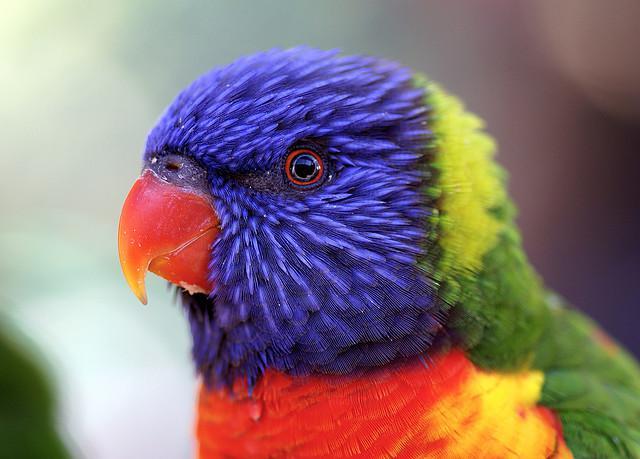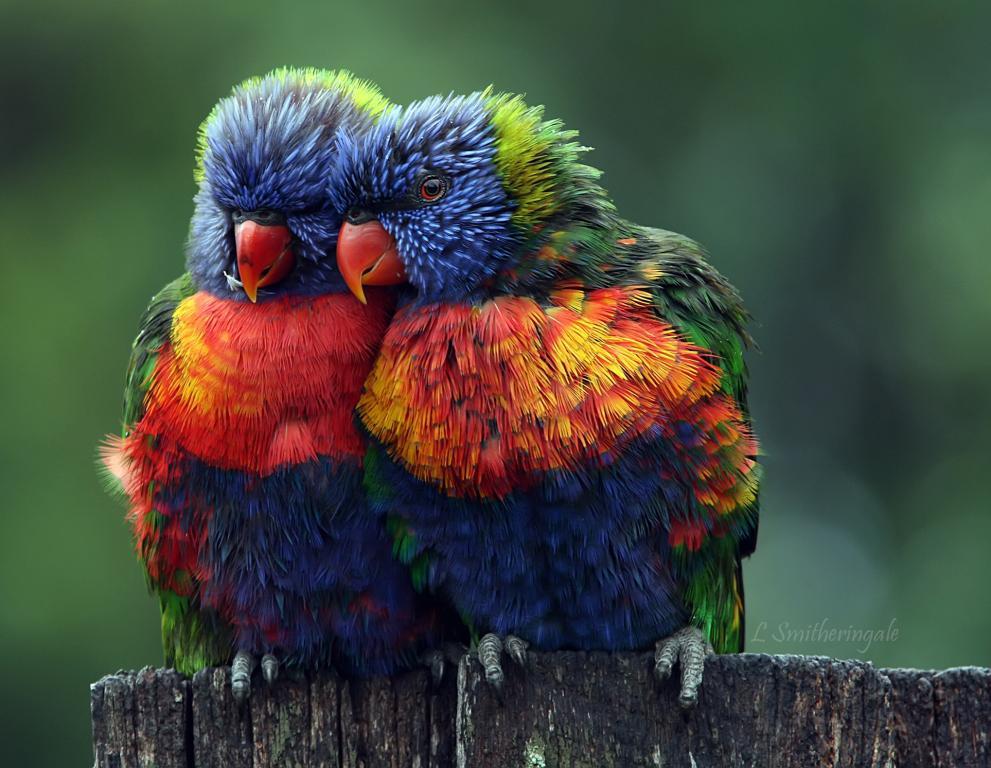The first image is the image on the left, the second image is the image on the right. Considering the images on both sides, is "There are four colorful birds in the pair of images." valid? Answer yes or no. No. The first image is the image on the left, the second image is the image on the right. Considering the images on both sides, is "There are three parrots." valid? Answer yes or no. Yes. 